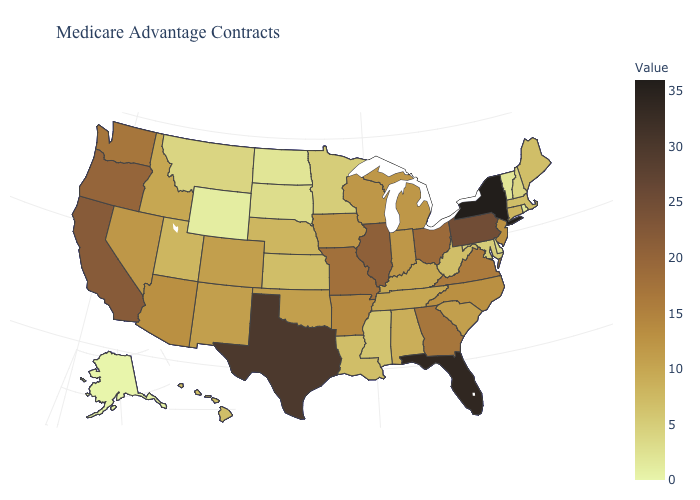Does Illinois have the highest value in the MidWest?
Write a very short answer. Yes. Does Louisiana have the lowest value in the South?
Keep it brief. No. Does Colorado have a higher value than Mississippi?
Concise answer only. Yes. Among the states that border Kentucky , does West Virginia have the lowest value?
Write a very short answer. Yes. Does Washington have a higher value than California?
Quick response, please. No. Among the states that border Washington , does Idaho have the highest value?
Answer briefly. No. 